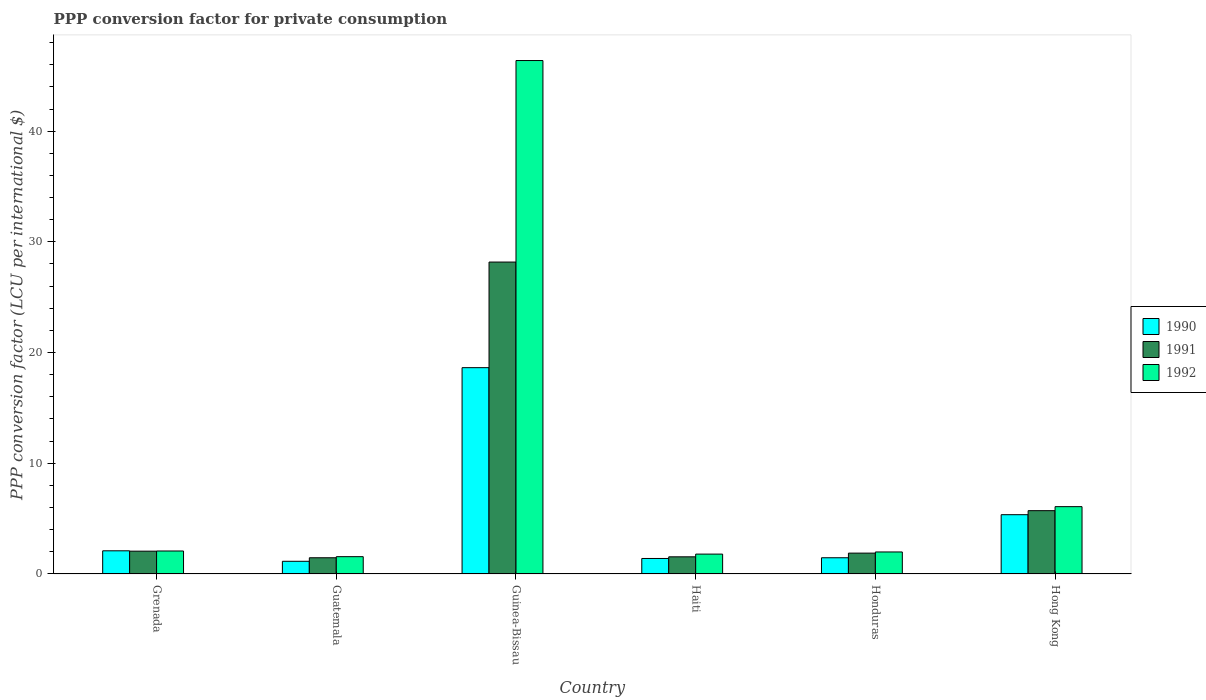How many bars are there on the 5th tick from the left?
Your answer should be compact. 3. What is the label of the 4th group of bars from the left?
Your answer should be compact. Haiti. What is the PPP conversion factor for private consumption in 1992 in Guatemala?
Offer a terse response. 1.56. Across all countries, what is the maximum PPP conversion factor for private consumption in 1990?
Make the answer very short. 18.64. Across all countries, what is the minimum PPP conversion factor for private consumption in 1990?
Provide a short and direct response. 1.15. In which country was the PPP conversion factor for private consumption in 1990 maximum?
Ensure brevity in your answer.  Guinea-Bissau. In which country was the PPP conversion factor for private consumption in 1992 minimum?
Your answer should be very brief. Guatemala. What is the total PPP conversion factor for private consumption in 1990 in the graph?
Provide a succinct answer. 30.1. What is the difference between the PPP conversion factor for private consumption in 1991 in Guinea-Bissau and that in Hong Kong?
Your answer should be very brief. 22.46. What is the difference between the PPP conversion factor for private consumption in 1992 in Grenada and the PPP conversion factor for private consumption in 1990 in Honduras?
Give a very brief answer. 0.61. What is the average PPP conversion factor for private consumption in 1990 per country?
Ensure brevity in your answer.  5.02. What is the difference between the PPP conversion factor for private consumption of/in 1991 and PPP conversion factor for private consumption of/in 1990 in Haiti?
Your answer should be very brief. 0.15. What is the ratio of the PPP conversion factor for private consumption in 1990 in Honduras to that in Hong Kong?
Your answer should be very brief. 0.27. Is the difference between the PPP conversion factor for private consumption in 1991 in Haiti and Honduras greater than the difference between the PPP conversion factor for private consumption in 1990 in Haiti and Honduras?
Ensure brevity in your answer.  No. What is the difference between the highest and the second highest PPP conversion factor for private consumption in 1990?
Offer a very short reply. 16.54. What is the difference between the highest and the lowest PPP conversion factor for private consumption in 1991?
Offer a very short reply. 26.71. What does the 2nd bar from the left in Guinea-Bissau represents?
Ensure brevity in your answer.  1991. Is it the case that in every country, the sum of the PPP conversion factor for private consumption in 1992 and PPP conversion factor for private consumption in 1990 is greater than the PPP conversion factor for private consumption in 1991?
Provide a succinct answer. Yes. How many bars are there?
Provide a short and direct response. 18. Are all the bars in the graph horizontal?
Make the answer very short. No. Are the values on the major ticks of Y-axis written in scientific E-notation?
Ensure brevity in your answer.  No. Does the graph contain grids?
Your answer should be compact. No. How many legend labels are there?
Give a very brief answer. 3. How are the legend labels stacked?
Offer a terse response. Vertical. What is the title of the graph?
Your response must be concise. PPP conversion factor for private consumption. What is the label or title of the Y-axis?
Your answer should be very brief. PPP conversion factor (LCU per international $). What is the PPP conversion factor (LCU per international $) of 1990 in Grenada?
Offer a terse response. 2.09. What is the PPP conversion factor (LCU per international $) of 1991 in Grenada?
Your answer should be compact. 2.06. What is the PPP conversion factor (LCU per international $) in 1992 in Grenada?
Offer a terse response. 2.08. What is the PPP conversion factor (LCU per international $) in 1990 in Guatemala?
Provide a short and direct response. 1.15. What is the PPP conversion factor (LCU per international $) of 1991 in Guatemala?
Your answer should be compact. 1.46. What is the PPP conversion factor (LCU per international $) of 1992 in Guatemala?
Your answer should be compact. 1.56. What is the PPP conversion factor (LCU per international $) in 1990 in Guinea-Bissau?
Your answer should be compact. 18.64. What is the PPP conversion factor (LCU per international $) in 1991 in Guinea-Bissau?
Your response must be concise. 28.18. What is the PPP conversion factor (LCU per international $) in 1992 in Guinea-Bissau?
Your answer should be compact. 46.38. What is the PPP conversion factor (LCU per international $) in 1990 in Haiti?
Offer a terse response. 1.4. What is the PPP conversion factor (LCU per international $) of 1991 in Haiti?
Make the answer very short. 1.55. What is the PPP conversion factor (LCU per international $) in 1992 in Haiti?
Provide a short and direct response. 1.8. What is the PPP conversion factor (LCU per international $) in 1990 in Honduras?
Your answer should be very brief. 1.47. What is the PPP conversion factor (LCU per international $) of 1991 in Honduras?
Keep it short and to the point. 1.88. What is the PPP conversion factor (LCU per international $) of 1992 in Honduras?
Offer a very short reply. 1.99. What is the PPP conversion factor (LCU per international $) in 1990 in Hong Kong?
Make the answer very short. 5.35. What is the PPP conversion factor (LCU per international $) in 1991 in Hong Kong?
Provide a short and direct response. 5.72. What is the PPP conversion factor (LCU per international $) in 1992 in Hong Kong?
Make the answer very short. 6.08. Across all countries, what is the maximum PPP conversion factor (LCU per international $) in 1990?
Offer a very short reply. 18.64. Across all countries, what is the maximum PPP conversion factor (LCU per international $) of 1991?
Offer a very short reply. 28.18. Across all countries, what is the maximum PPP conversion factor (LCU per international $) in 1992?
Your answer should be very brief. 46.38. Across all countries, what is the minimum PPP conversion factor (LCU per international $) of 1990?
Your answer should be very brief. 1.15. Across all countries, what is the minimum PPP conversion factor (LCU per international $) of 1991?
Offer a very short reply. 1.46. Across all countries, what is the minimum PPP conversion factor (LCU per international $) of 1992?
Give a very brief answer. 1.56. What is the total PPP conversion factor (LCU per international $) in 1990 in the graph?
Keep it short and to the point. 30.1. What is the total PPP conversion factor (LCU per international $) of 1991 in the graph?
Give a very brief answer. 40.86. What is the total PPP conversion factor (LCU per international $) in 1992 in the graph?
Offer a terse response. 59.88. What is the difference between the PPP conversion factor (LCU per international $) of 1990 in Grenada and that in Guatemala?
Give a very brief answer. 0.95. What is the difference between the PPP conversion factor (LCU per international $) in 1991 in Grenada and that in Guatemala?
Keep it short and to the point. 0.6. What is the difference between the PPP conversion factor (LCU per international $) of 1992 in Grenada and that in Guatemala?
Provide a succinct answer. 0.51. What is the difference between the PPP conversion factor (LCU per international $) in 1990 in Grenada and that in Guinea-Bissau?
Offer a terse response. -16.54. What is the difference between the PPP conversion factor (LCU per international $) in 1991 in Grenada and that in Guinea-Bissau?
Offer a very short reply. -26.11. What is the difference between the PPP conversion factor (LCU per international $) in 1992 in Grenada and that in Guinea-Bissau?
Ensure brevity in your answer.  -44.3. What is the difference between the PPP conversion factor (LCU per international $) of 1990 in Grenada and that in Haiti?
Give a very brief answer. 0.69. What is the difference between the PPP conversion factor (LCU per international $) of 1991 in Grenada and that in Haiti?
Provide a short and direct response. 0.51. What is the difference between the PPP conversion factor (LCU per international $) in 1992 in Grenada and that in Haiti?
Your answer should be very brief. 0.28. What is the difference between the PPP conversion factor (LCU per international $) in 1990 in Grenada and that in Honduras?
Provide a succinct answer. 0.63. What is the difference between the PPP conversion factor (LCU per international $) of 1991 in Grenada and that in Honduras?
Offer a terse response. 0.18. What is the difference between the PPP conversion factor (LCU per international $) in 1992 in Grenada and that in Honduras?
Your answer should be very brief. 0.09. What is the difference between the PPP conversion factor (LCU per international $) in 1990 in Grenada and that in Hong Kong?
Ensure brevity in your answer.  -3.26. What is the difference between the PPP conversion factor (LCU per international $) of 1991 in Grenada and that in Hong Kong?
Give a very brief answer. -3.66. What is the difference between the PPP conversion factor (LCU per international $) in 1992 in Grenada and that in Hong Kong?
Offer a very short reply. -4.01. What is the difference between the PPP conversion factor (LCU per international $) in 1990 in Guatemala and that in Guinea-Bissau?
Provide a short and direct response. -17.49. What is the difference between the PPP conversion factor (LCU per international $) in 1991 in Guatemala and that in Guinea-Bissau?
Your response must be concise. -26.71. What is the difference between the PPP conversion factor (LCU per international $) in 1992 in Guatemala and that in Guinea-Bissau?
Keep it short and to the point. -44.81. What is the difference between the PPP conversion factor (LCU per international $) of 1990 in Guatemala and that in Haiti?
Your response must be concise. -0.25. What is the difference between the PPP conversion factor (LCU per international $) of 1991 in Guatemala and that in Haiti?
Offer a terse response. -0.09. What is the difference between the PPP conversion factor (LCU per international $) of 1992 in Guatemala and that in Haiti?
Offer a very short reply. -0.23. What is the difference between the PPP conversion factor (LCU per international $) in 1990 in Guatemala and that in Honduras?
Your answer should be compact. -0.32. What is the difference between the PPP conversion factor (LCU per international $) of 1991 in Guatemala and that in Honduras?
Your response must be concise. -0.42. What is the difference between the PPP conversion factor (LCU per international $) of 1992 in Guatemala and that in Honduras?
Give a very brief answer. -0.42. What is the difference between the PPP conversion factor (LCU per international $) of 1990 in Guatemala and that in Hong Kong?
Offer a terse response. -4.21. What is the difference between the PPP conversion factor (LCU per international $) of 1991 in Guatemala and that in Hong Kong?
Provide a short and direct response. -4.25. What is the difference between the PPP conversion factor (LCU per international $) of 1992 in Guatemala and that in Hong Kong?
Make the answer very short. -4.52. What is the difference between the PPP conversion factor (LCU per international $) in 1990 in Guinea-Bissau and that in Haiti?
Provide a short and direct response. 17.24. What is the difference between the PPP conversion factor (LCU per international $) of 1991 in Guinea-Bissau and that in Haiti?
Keep it short and to the point. 26.63. What is the difference between the PPP conversion factor (LCU per international $) in 1992 in Guinea-Bissau and that in Haiti?
Make the answer very short. 44.58. What is the difference between the PPP conversion factor (LCU per international $) of 1990 in Guinea-Bissau and that in Honduras?
Your answer should be compact. 17.17. What is the difference between the PPP conversion factor (LCU per international $) in 1991 in Guinea-Bissau and that in Honduras?
Keep it short and to the point. 26.29. What is the difference between the PPP conversion factor (LCU per international $) of 1992 in Guinea-Bissau and that in Honduras?
Offer a very short reply. 44.39. What is the difference between the PPP conversion factor (LCU per international $) in 1990 in Guinea-Bissau and that in Hong Kong?
Keep it short and to the point. 13.28. What is the difference between the PPP conversion factor (LCU per international $) of 1991 in Guinea-Bissau and that in Hong Kong?
Your answer should be compact. 22.46. What is the difference between the PPP conversion factor (LCU per international $) in 1992 in Guinea-Bissau and that in Hong Kong?
Provide a short and direct response. 40.29. What is the difference between the PPP conversion factor (LCU per international $) in 1990 in Haiti and that in Honduras?
Make the answer very short. -0.07. What is the difference between the PPP conversion factor (LCU per international $) in 1991 in Haiti and that in Honduras?
Offer a terse response. -0.33. What is the difference between the PPP conversion factor (LCU per international $) of 1992 in Haiti and that in Honduras?
Provide a short and direct response. -0.19. What is the difference between the PPP conversion factor (LCU per international $) of 1990 in Haiti and that in Hong Kong?
Ensure brevity in your answer.  -3.95. What is the difference between the PPP conversion factor (LCU per international $) of 1991 in Haiti and that in Hong Kong?
Offer a terse response. -4.17. What is the difference between the PPP conversion factor (LCU per international $) in 1992 in Haiti and that in Hong Kong?
Your answer should be compact. -4.29. What is the difference between the PPP conversion factor (LCU per international $) in 1990 in Honduras and that in Hong Kong?
Your response must be concise. -3.89. What is the difference between the PPP conversion factor (LCU per international $) of 1991 in Honduras and that in Hong Kong?
Give a very brief answer. -3.84. What is the difference between the PPP conversion factor (LCU per international $) of 1992 in Honduras and that in Hong Kong?
Your response must be concise. -4.09. What is the difference between the PPP conversion factor (LCU per international $) of 1990 in Grenada and the PPP conversion factor (LCU per international $) of 1991 in Guatemala?
Ensure brevity in your answer.  0.63. What is the difference between the PPP conversion factor (LCU per international $) in 1990 in Grenada and the PPP conversion factor (LCU per international $) in 1992 in Guatemala?
Offer a terse response. 0.53. What is the difference between the PPP conversion factor (LCU per international $) in 1991 in Grenada and the PPP conversion factor (LCU per international $) in 1992 in Guatemala?
Your response must be concise. 0.5. What is the difference between the PPP conversion factor (LCU per international $) in 1990 in Grenada and the PPP conversion factor (LCU per international $) in 1991 in Guinea-Bissau?
Provide a succinct answer. -26.08. What is the difference between the PPP conversion factor (LCU per international $) in 1990 in Grenada and the PPP conversion factor (LCU per international $) in 1992 in Guinea-Bissau?
Keep it short and to the point. -44.28. What is the difference between the PPP conversion factor (LCU per international $) in 1991 in Grenada and the PPP conversion factor (LCU per international $) in 1992 in Guinea-Bissau?
Your response must be concise. -44.32. What is the difference between the PPP conversion factor (LCU per international $) in 1990 in Grenada and the PPP conversion factor (LCU per international $) in 1991 in Haiti?
Provide a short and direct response. 0.54. What is the difference between the PPP conversion factor (LCU per international $) of 1990 in Grenada and the PPP conversion factor (LCU per international $) of 1992 in Haiti?
Offer a terse response. 0.3. What is the difference between the PPP conversion factor (LCU per international $) of 1991 in Grenada and the PPP conversion factor (LCU per international $) of 1992 in Haiti?
Your response must be concise. 0.27. What is the difference between the PPP conversion factor (LCU per international $) in 1990 in Grenada and the PPP conversion factor (LCU per international $) in 1991 in Honduras?
Your response must be concise. 0.21. What is the difference between the PPP conversion factor (LCU per international $) of 1990 in Grenada and the PPP conversion factor (LCU per international $) of 1992 in Honduras?
Ensure brevity in your answer.  0.1. What is the difference between the PPP conversion factor (LCU per international $) in 1991 in Grenada and the PPP conversion factor (LCU per international $) in 1992 in Honduras?
Offer a terse response. 0.07. What is the difference between the PPP conversion factor (LCU per international $) in 1990 in Grenada and the PPP conversion factor (LCU per international $) in 1991 in Hong Kong?
Make the answer very short. -3.63. What is the difference between the PPP conversion factor (LCU per international $) in 1990 in Grenada and the PPP conversion factor (LCU per international $) in 1992 in Hong Kong?
Make the answer very short. -3.99. What is the difference between the PPP conversion factor (LCU per international $) in 1991 in Grenada and the PPP conversion factor (LCU per international $) in 1992 in Hong Kong?
Your response must be concise. -4.02. What is the difference between the PPP conversion factor (LCU per international $) of 1990 in Guatemala and the PPP conversion factor (LCU per international $) of 1991 in Guinea-Bissau?
Provide a succinct answer. -27.03. What is the difference between the PPP conversion factor (LCU per international $) in 1990 in Guatemala and the PPP conversion factor (LCU per international $) in 1992 in Guinea-Bissau?
Ensure brevity in your answer.  -45.23. What is the difference between the PPP conversion factor (LCU per international $) of 1991 in Guatemala and the PPP conversion factor (LCU per international $) of 1992 in Guinea-Bissau?
Provide a short and direct response. -44.91. What is the difference between the PPP conversion factor (LCU per international $) of 1990 in Guatemala and the PPP conversion factor (LCU per international $) of 1991 in Haiti?
Offer a very short reply. -0.4. What is the difference between the PPP conversion factor (LCU per international $) in 1990 in Guatemala and the PPP conversion factor (LCU per international $) in 1992 in Haiti?
Give a very brief answer. -0.65. What is the difference between the PPP conversion factor (LCU per international $) in 1991 in Guatemala and the PPP conversion factor (LCU per international $) in 1992 in Haiti?
Your response must be concise. -0.33. What is the difference between the PPP conversion factor (LCU per international $) of 1990 in Guatemala and the PPP conversion factor (LCU per international $) of 1991 in Honduras?
Provide a short and direct response. -0.74. What is the difference between the PPP conversion factor (LCU per international $) of 1990 in Guatemala and the PPP conversion factor (LCU per international $) of 1992 in Honduras?
Offer a very short reply. -0.84. What is the difference between the PPP conversion factor (LCU per international $) of 1991 in Guatemala and the PPP conversion factor (LCU per international $) of 1992 in Honduras?
Make the answer very short. -0.52. What is the difference between the PPP conversion factor (LCU per international $) of 1990 in Guatemala and the PPP conversion factor (LCU per international $) of 1991 in Hong Kong?
Keep it short and to the point. -4.57. What is the difference between the PPP conversion factor (LCU per international $) of 1990 in Guatemala and the PPP conversion factor (LCU per international $) of 1992 in Hong Kong?
Provide a short and direct response. -4.94. What is the difference between the PPP conversion factor (LCU per international $) in 1991 in Guatemala and the PPP conversion factor (LCU per international $) in 1992 in Hong Kong?
Offer a terse response. -4.62. What is the difference between the PPP conversion factor (LCU per international $) in 1990 in Guinea-Bissau and the PPP conversion factor (LCU per international $) in 1991 in Haiti?
Provide a short and direct response. 17.09. What is the difference between the PPP conversion factor (LCU per international $) of 1990 in Guinea-Bissau and the PPP conversion factor (LCU per international $) of 1992 in Haiti?
Give a very brief answer. 16.84. What is the difference between the PPP conversion factor (LCU per international $) of 1991 in Guinea-Bissau and the PPP conversion factor (LCU per international $) of 1992 in Haiti?
Your answer should be very brief. 26.38. What is the difference between the PPP conversion factor (LCU per international $) in 1990 in Guinea-Bissau and the PPP conversion factor (LCU per international $) in 1991 in Honduras?
Ensure brevity in your answer.  16.75. What is the difference between the PPP conversion factor (LCU per international $) in 1990 in Guinea-Bissau and the PPP conversion factor (LCU per international $) in 1992 in Honduras?
Keep it short and to the point. 16.65. What is the difference between the PPP conversion factor (LCU per international $) in 1991 in Guinea-Bissau and the PPP conversion factor (LCU per international $) in 1992 in Honduras?
Your response must be concise. 26.19. What is the difference between the PPP conversion factor (LCU per international $) of 1990 in Guinea-Bissau and the PPP conversion factor (LCU per international $) of 1991 in Hong Kong?
Offer a terse response. 12.92. What is the difference between the PPP conversion factor (LCU per international $) in 1990 in Guinea-Bissau and the PPP conversion factor (LCU per international $) in 1992 in Hong Kong?
Provide a short and direct response. 12.55. What is the difference between the PPP conversion factor (LCU per international $) in 1991 in Guinea-Bissau and the PPP conversion factor (LCU per international $) in 1992 in Hong Kong?
Your response must be concise. 22.09. What is the difference between the PPP conversion factor (LCU per international $) of 1990 in Haiti and the PPP conversion factor (LCU per international $) of 1991 in Honduras?
Your answer should be compact. -0.48. What is the difference between the PPP conversion factor (LCU per international $) in 1990 in Haiti and the PPP conversion factor (LCU per international $) in 1992 in Honduras?
Keep it short and to the point. -0.59. What is the difference between the PPP conversion factor (LCU per international $) of 1991 in Haiti and the PPP conversion factor (LCU per international $) of 1992 in Honduras?
Provide a short and direct response. -0.44. What is the difference between the PPP conversion factor (LCU per international $) in 1990 in Haiti and the PPP conversion factor (LCU per international $) in 1991 in Hong Kong?
Ensure brevity in your answer.  -4.32. What is the difference between the PPP conversion factor (LCU per international $) in 1990 in Haiti and the PPP conversion factor (LCU per international $) in 1992 in Hong Kong?
Your answer should be very brief. -4.68. What is the difference between the PPP conversion factor (LCU per international $) of 1991 in Haiti and the PPP conversion factor (LCU per international $) of 1992 in Hong Kong?
Your answer should be compact. -4.53. What is the difference between the PPP conversion factor (LCU per international $) in 1990 in Honduras and the PPP conversion factor (LCU per international $) in 1991 in Hong Kong?
Offer a terse response. -4.25. What is the difference between the PPP conversion factor (LCU per international $) of 1990 in Honduras and the PPP conversion factor (LCU per international $) of 1992 in Hong Kong?
Offer a terse response. -4.62. What is the difference between the PPP conversion factor (LCU per international $) in 1991 in Honduras and the PPP conversion factor (LCU per international $) in 1992 in Hong Kong?
Your answer should be very brief. -4.2. What is the average PPP conversion factor (LCU per international $) of 1990 per country?
Your response must be concise. 5.02. What is the average PPP conversion factor (LCU per international $) in 1991 per country?
Provide a short and direct response. 6.81. What is the average PPP conversion factor (LCU per international $) of 1992 per country?
Offer a very short reply. 9.98. What is the difference between the PPP conversion factor (LCU per international $) of 1990 and PPP conversion factor (LCU per international $) of 1991 in Grenada?
Make the answer very short. 0.03. What is the difference between the PPP conversion factor (LCU per international $) in 1990 and PPP conversion factor (LCU per international $) in 1992 in Grenada?
Provide a succinct answer. 0.02. What is the difference between the PPP conversion factor (LCU per international $) of 1991 and PPP conversion factor (LCU per international $) of 1992 in Grenada?
Provide a short and direct response. -0.01. What is the difference between the PPP conversion factor (LCU per international $) in 1990 and PPP conversion factor (LCU per international $) in 1991 in Guatemala?
Make the answer very short. -0.32. What is the difference between the PPP conversion factor (LCU per international $) of 1990 and PPP conversion factor (LCU per international $) of 1992 in Guatemala?
Provide a short and direct response. -0.42. What is the difference between the PPP conversion factor (LCU per international $) in 1991 and PPP conversion factor (LCU per international $) in 1992 in Guatemala?
Your answer should be very brief. -0.1. What is the difference between the PPP conversion factor (LCU per international $) of 1990 and PPP conversion factor (LCU per international $) of 1991 in Guinea-Bissau?
Offer a very short reply. -9.54. What is the difference between the PPP conversion factor (LCU per international $) of 1990 and PPP conversion factor (LCU per international $) of 1992 in Guinea-Bissau?
Keep it short and to the point. -27.74. What is the difference between the PPP conversion factor (LCU per international $) of 1991 and PPP conversion factor (LCU per international $) of 1992 in Guinea-Bissau?
Provide a succinct answer. -18.2. What is the difference between the PPP conversion factor (LCU per international $) in 1990 and PPP conversion factor (LCU per international $) in 1991 in Haiti?
Your answer should be very brief. -0.15. What is the difference between the PPP conversion factor (LCU per international $) of 1990 and PPP conversion factor (LCU per international $) of 1992 in Haiti?
Offer a very short reply. -0.4. What is the difference between the PPP conversion factor (LCU per international $) of 1991 and PPP conversion factor (LCU per international $) of 1992 in Haiti?
Keep it short and to the point. -0.25. What is the difference between the PPP conversion factor (LCU per international $) in 1990 and PPP conversion factor (LCU per international $) in 1991 in Honduras?
Provide a short and direct response. -0.42. What is the difference between the PPP conversion factor (LCU per international $) in 1990 and PPP conversion factor (LCU per international $) in 1992 in Honduras?
Make the answer very short. -0.52. What is the difference between the PPP conversion factor (LCU per international $) in 1991 and PPP conversion factor (LCU per international $) in 1992 in Honduras?
Offer a very short reply. -0.1. What is the difference between the PPP conversion factor (LCU per international $) in 1990 and PPP conversion factor (LCU per international $) in 1991 in Hong Kong?
Keep it short and to the point. -0.37. What is the difference between the PPP conversion factor (LCU per international $) of 1990 and PPP conversion factor (LCU per international $) of 1992 in Hong Kong?
Your response must be concise. -0.73. What is the difference between the PPP conversion factor (LCU per international $) in 1991 and PPP conversion factor (LCU per international $) in 1992 in Hong Kong?
Your answer should be compact. -0.36. What is the ratio of the PPP conversion factor (LCU per international $) of 1990 in Grenada to that in Guatemala?
Offer a terse response. 1.83. What is the ratio of the PPP conversion factor (LCU per international $) of 1991 in Grenada to that in Guatemala?
Provide a succinct answer. 1.41. What is the ratio of the PPP conversion factor (LCU per international $) of 1992 in Grenada to that in Guatemala?
Offer a very short reply. 1.33. What is the ratio of the PPP conversion factor (LCU per international $) of 1990 in Grenada to that in Guinea-Bissau?
Your answer should be very brief. 0.11. What is the ratio of the PPP conversion factor (LCU per international $) of 1991 in Grenada to that in Guinea-Bissau?
Ensure brevity in your answer.  0.07. What is the ratio of the PPP conversion factor (LCU per international $) of 1992 in Grenada to that in Guinea-Bissau?
Offer a very short reply. 0.04. What is the ratio of the PPP conversion factor (LCU per international $) of 1990 in Grenada to that in Haiti?
Your answer should be compact. 1.49. What is the ratio of the PPP conversion factor (LCU per international $) of 1991 in Grenada to that in Haiti?
Keep it short and to the point. 1.33. What is the ratio of the PPP conversion factor (LCU per international $) in 1992 in Grenada to that in Haiti?
Offer a terse response. 1.16. What is the ratio of the PPP conversion factor (LCU per international $) in 1990 in Grenada to that in Honduras?
Give a very brief answer. 1.43. What is the ratio of the PPP conversion factor (LCU per international $) in 1991 in Grenada to that in Honduras?
Your answer should be compact. 1.09. What is the ratio of the PPP conversion factor (LCU per international $) in 1992 in Grenada to that in Honduras?
Offer a terse response. 1.04. What is the ratio of the PPP conversion factor (LCU per international $) in 1990 in Grenada to that in Hong Kong?
Provide a short and direct response. 0.39. What is the ratio of the PPP conversion factor (LCU per international $) of 1991 in Grenada to that in Hong Kong?
Give a very brief answer. 0.36. What is the ratio of the PPP conversion factor (LCU per international $) in 1992 in Grenada to that in Hong Kong?
Ensure brevity in your answer.  0.34. What is the ratio of the PPP conversion factor (LCU per international $) of 1990 in Guatemala to that in Guinea-Bissau?
Make the answer very short. 0.06. What is the ratio of the PPP conversion factor (LCU per international $) in 1991 in Guatemala to that in Guinea-Bissau?
Your response must be concise. 0.05. What is the ratio of the PPP conversion factor (LCU per international $) in 1992 in Guatemala to that in Guinea-Bissau?
Offer a very short reply. 0.03. What is the ratio of the PPP conversion factor (LCU per international $) in 1990 in Guatemala to that in Haiti?
Provide a short and direct response. 0.82. What is the ratio of the PPP conversion factor (LCU per international $) of 1991 in Guatemala to that in Haiti?
Offer a very short reply. 0.94. What is the ratio of the PPP conversion factor (LCU per international $) in 1992 in Guatemala to that in Haiti?
Make the answer very short. 0.87. What is the ratio of the PPP conversion factor (LCU per international $) in 1990 in Guatemala to that in Honduras?
Keep it short and to the point. 0.78. What is the ratio of the PPP conversion factor (LCU per international $) in 1991 in Guatemala to that in Honduras?
Your response must be concise. 0.78. What is the ratio of the PPP conversion factor (LCU per international $) in 1992 in Guatemala to that in Honduras?
Provide a short and direct response. 0.79. What is the ratio of the PPP conversion factor (LCU per international $) in 1990 in Guatemala to that in Hong Kong?
Provide a succinct answer. 0.21. What is the ratio of the PPP conversion factor (LCU per international $) in 1991 in Guatemala to that in Hong Kong?
Keep it short and to the point. 0.26. What is the ratio of the PPP conversion factor (LCU per international $) of 1992 in Guatemala to that in Hong Kong?
Make the answer very short. 0.26. What is the ratio of the PPP conversion factor (LCU per international $) in 1990 in Guinea-Bissau to that in Haiti?
Ensure brevity in your answer.  13.31. What is the ratio of the PPP conversion factor (LCU per international $) in 1991 in Guinea-Bissau to that in Haiti?
Keep it short and to the point. 18.17. What is the ratio of the PPP conversion factor (LCU per international $) of 1992 in Guinea-Bissau to that in Haiti?
Make the answer very short. 25.82. What is the ratio of the PPP conversion factor (LCU per international $) in 1990 in Guinea-Bissau to that in Honduras?
Offer a very short reply. 12.71. What is the ratio of the PPP conversion factor (LCU per international $) in 1991 in Guinea-Bissau to that in Honduras?
Offer a terse response. 14.96. What is the ratio of the PPP conversion factor (LCU per international $) in 1992 in Guinea-Bissau to that in Honduras?
Your response must be concise. 23.32. What is the ratio of the PPP conversion factor (LCU per international $) of 1990 in Guinea-Bissau to that in Hong Kong?
Keep it short and to the point. 3.48. What is the ratio of the PPP conversion factor (LCU per international $) of 1991 in Guinea-Bissau to that in Hong Kong?
Offer a very short reply. 4.93. What is the ratio of the PPP conversion factor (LCU per international $) in 1992 in Guinea-Bissau to that in Hong Kong?
Offer a terse response. 7.63. What is the ratio of the PPP conversion factor (LCU per international $) in 1990 in Haiti to that in Honduras?
Your answer should be compact. 0.96. What is the ratio of the PPP conversion factor (LCU per international $) in 1991 in Haiti to that in Honduras?
Offer a terse response. 0.82. What is the ratio of the PPP conversion factor (LCU per international $) of 1992 in Haiti to that in Honduras?
Your answer should be very brief. 0.9. What is the ratio of the PPP conversion factor (LCU per international $) of 1990 in Haiti to that in Hong Kong?
Make the answer very short. 0.26. What is the ratio of the PPP conversion factor (LCU per international $) of 1991 in Haiti to that in Hong Kong?
Keep it short and to the point. 0.27. What is the ratio of the PPP conversion factor (LCU per international $) of 1992 in Haiti to that in Hong Kong?
Offer a terse response. 0.3. What is the ratio of the PPP conversion factor (LCU per international $) in 1990 in Honduras to that in Hong Kong?
Your response must be concise. 0.27. What is the ratio of the PPP conversion factor (LCU per international $) in 1991 in Honduras to that in Hong Kong?
Offer a terse response. 0.33. What is the ratio of the PPP conversion factor (LCU per international $) in 1992 in Honduras to that in Hong Kong?
Your response must be concise. 0.33. What is the difference between the highest and the second highest PPP conversion factor (LCU per international $) in 1990?
Provide a short and direct response. 13.28. What is the difference between the highest and the second highest PPP conversion factor (LCU per international $) in 1991?
Offer a very short reply. 22.46. What is the difference between the highest and the second highest PPP conversion factor (LCU per international $) of 1992?
Keep it short and to the point. 40.29. What is the difference between the highest and the lowest PPP conversion factor (LCU per international $) in 1990?
Ensure brevity in your answer.  17.49. What is the difference between the highest and the lowest PPP conversion factor (LCU per international $) of 1991?
Provide a succinct answer. 26.71. What is the difference between the highest and the lowest PPP conversion factor (LCU per international $) in 1992?
Offer a very short reply. 44.81. 